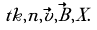Convert formula to latex. <formula><loc_0><loc_0><loc_500><loc_500>\ t k , n , \vec { v } , \vec { B } , X .</formula> 